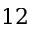Convert formula to latex. <formula><loc_0><loc_0><loc_500><loc_500>1 2</formula> 